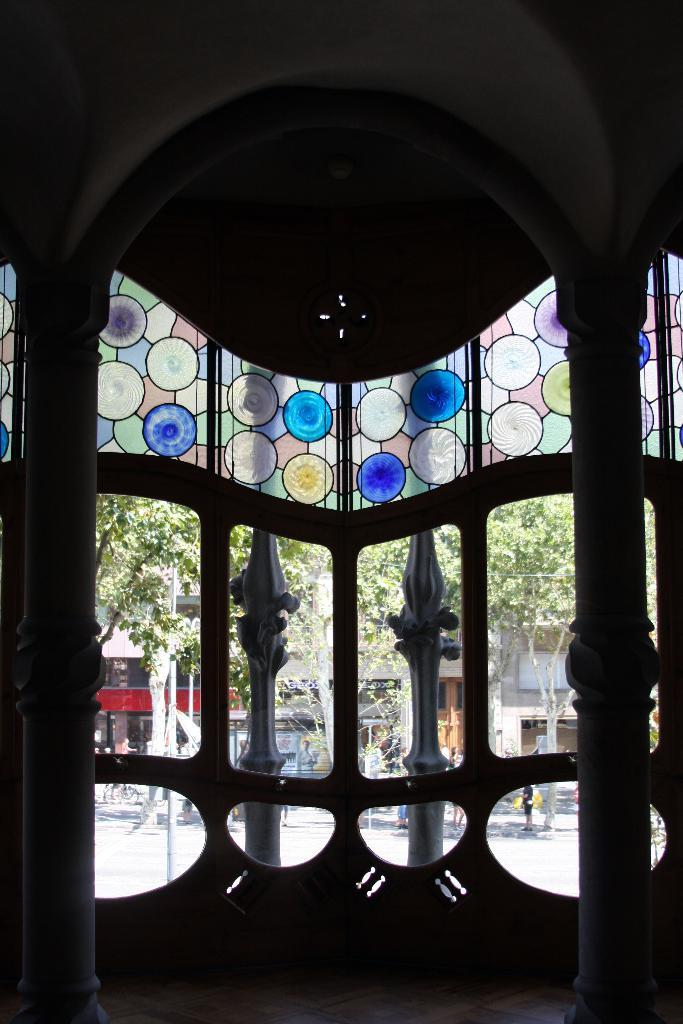What type of structure can be seen in the image? There is an arch in the image, which is a type of structure. Are there any other architectural features present in the image? Yes, there are pillars visible in the image. What material can be seen in the image? Glass is visible in the image. What type of environment is depicted in the image? There are buildings, trees, and the ground visible in the image, suggesting an urban or suburban setting. What object can be seen on the board in the image? The facts do not specify any object on the board, so we cannot answer that question definitively. Can you tell me how many crayons are on the ground in the image? There are no crayons present in the image; it features an arch, pillars, glass, buildings, trees, and a board. What type of lumber is used to construct the buildings in the image? The facts do not specify the type of lumber used to construct the buildings, so we cannot answer that question definitively. 